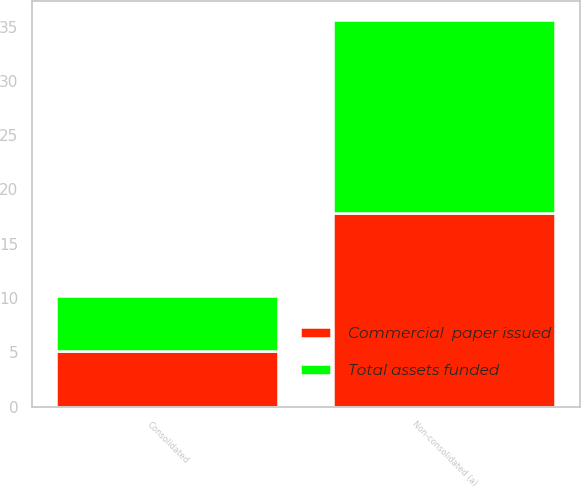Convert chart to OTSL. <chart><loc_0><loc_0><loc_500><loc_500><stacked_bar_chart><ecel><fcel>Consolidated<fcel>Non-consolidated (a)<nl><fcel>Total assets funded<fcel>5.1<fcel>17.8<nl><fcel>Commercial  paper issued<fcel>5.1<fcel>17.8<nl></chart> 